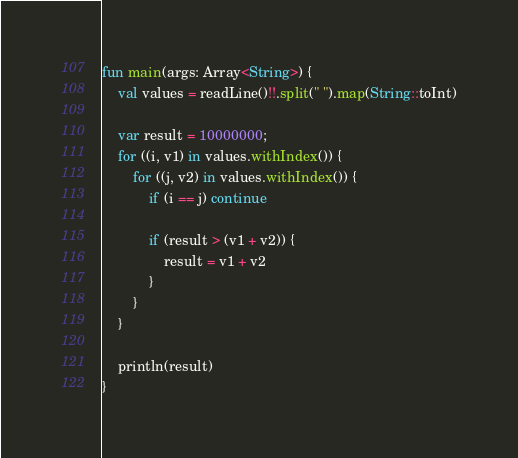<code> <loc_0><loc_0><loc_500><loc_500><_Kotlin_>fun main(args: Array<String>) {
    val values = readLine()!!.split(" ").map(String::toInt)

    var result = 10000000;
    for ((i, v1) in values.withIndex()) {
        for ((j, v2) in values.withIndex()) {
            if (i == j) continue

            if (result > (v1 + v2)) {
                result = v1 + v2
            }
        }
    }

    println(result)
}</code> 